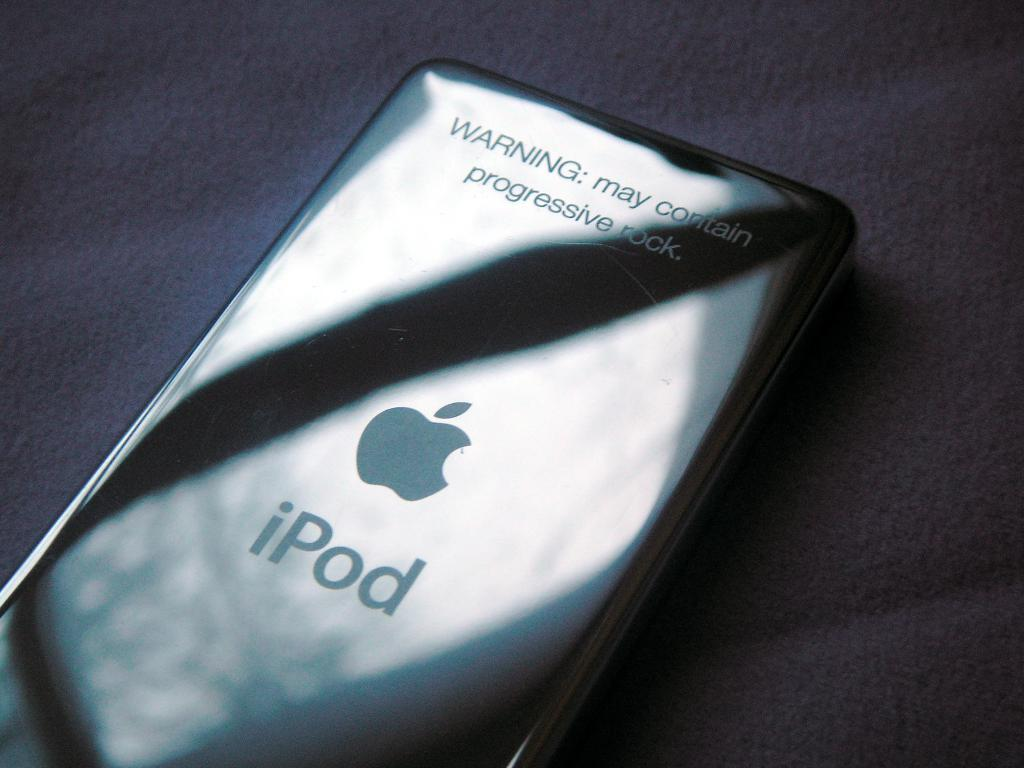<image>
Create a compact narrative representing the image presented. a gray iPod that has an apple logo on it 